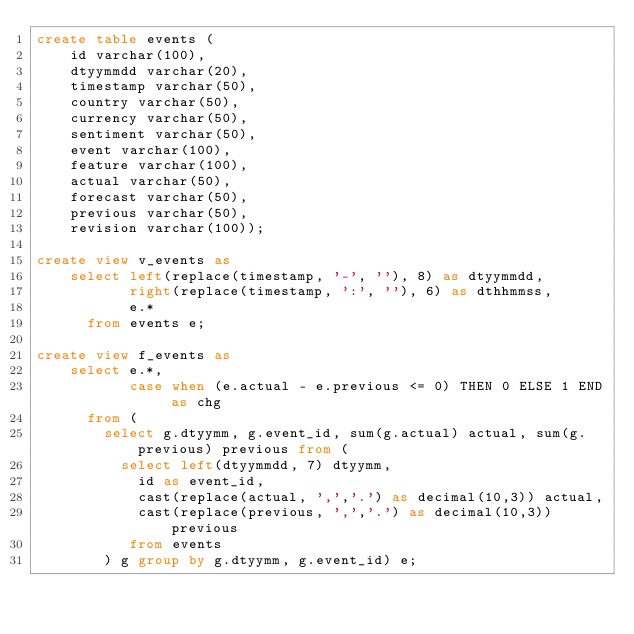Convert code to text. <code><loc_0><loc_0><loc_500><loc_500><_SQL_>create table events (
    id varchar(100),
    dtyymmdd varchar(20),
    timestamp varchar(50),
    country varchar(50),
    currency varchar(50),
    sentiment varchar(50),
    event varchar(100),
    feature varchar(100),
    actual varchar(50),
    forecast varchar(50),
    previous varchar(50),
    revision varchar(100));

create view v_events as
    select left(replace(timestamp, '-', ''), 8) as dtyymmdd,
           right(replace(timestamp, ':', ''), 6) as dthhmmss,
           e.*
      from events e;

create view f_events as
    select e.*,
           case when (e.actual - e.previous <= 0) THEN 0 ELSE 1 END as chg
      from (
        select g.dtyymm, g.event_id, sum(g.actual) actual, sum(g.previous) previous from (
          select left(dtyymmdd, 7) dtyymm,
            id as event_id,
            cast(replace(actual, ',','.') as decimal(10,3)) actual,
            cast(replace(previous, ',','.') as decimal(10,3)) previous
           from events
        ) g group by g.dtyymm, g.event_id) e;
</code> 